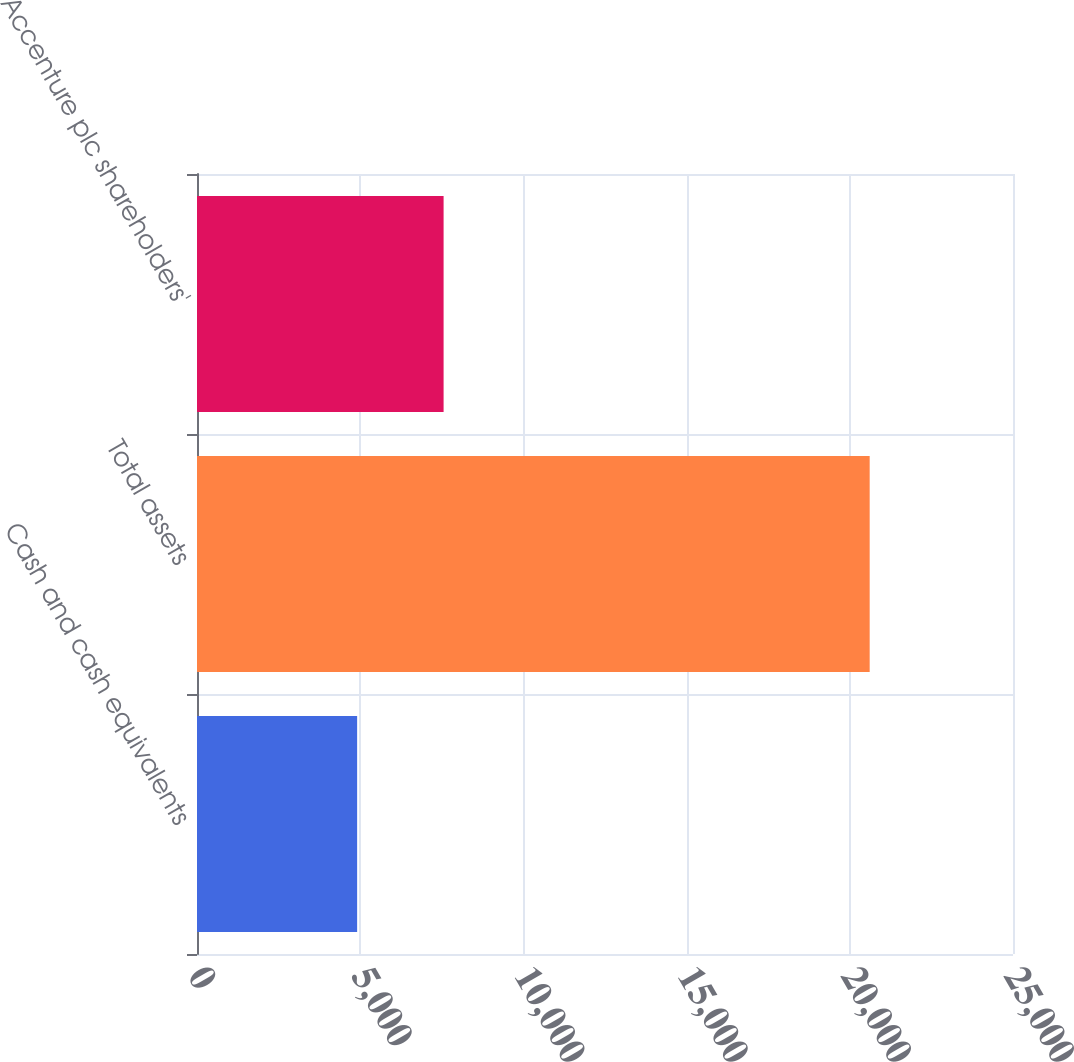Convert chart to OTSL. <chart><loc_0><loc_0><loc_500><loc_500><bar_chart><fcel>Cash and cash equivalents<fcel>Total assets<fcel>Accenture plc shareholders'<nl><fcel>4906<fcel>20609<fcel>7555<nl></chart> 